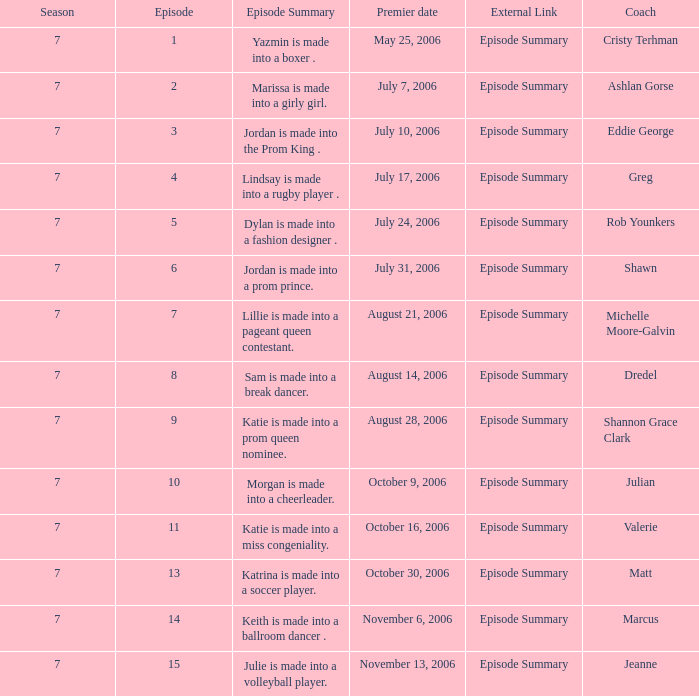How many episodes have a debut date of july 24, 2006? 1.0. 